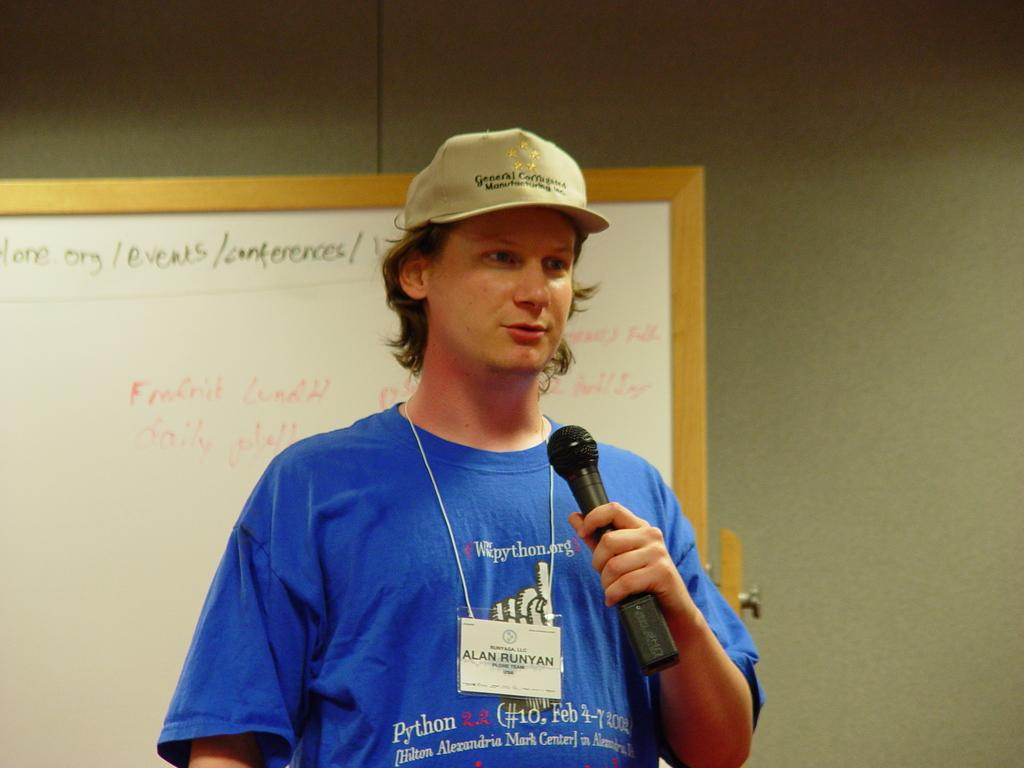Who is present in the image? There is a man in the image. What is the man doing in the image? The man is standing in the image. What is the man wearing on his head? The man is wearing a cap in the image. What is the man holding in the image? The man is holding a microphone in the image. What can be seen in the background of the image? There is a board visible in the image. What type of destruction is the man causing with the microphone in the image? There is no destruction present in the image; the man is simply holding a microphone. 